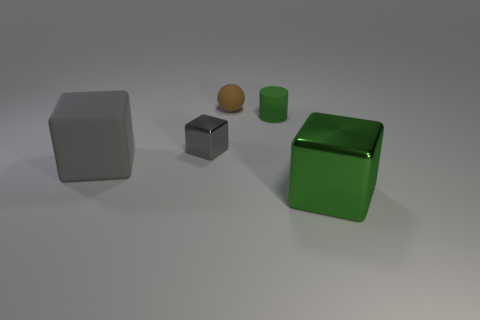Is there a small brown ball that has the same material as the small green thing?
Provide a short and direct response. Yes. Is the brown sphere made of the same material as the gray cube that is left of the tiny gray object?
Your response must be concise. Yes. There is a metal block that is the same size as the rubber ball; what is its color?
Your response must be concise. Gray. There is a metallic thing that is to the left of the big block that is in front of the matte block; how big is it?
Offer a terse response. Small. Is the color of the large rubber object the same as the small shiny block that is in front of the ball?
Keep it short and to the point. Yes. Are there fewer tiny green objects in front of the tiny gray metal block than blue rubber cubes?
Your answer should be very brief. No. What number of other things are the same size as the brown ball?
Provide a succinct answer. 2. There is a small thing to the left of the small brown rubber object; does it have the same shape as the big green thing?
Provide a succinct answer. Yes. Are there more small brown matte objects that are in front of the big gray matte cube than big green matte cylinders?
Make the answer very short. No. The thing that is behind the big gray object and in front of the small green matte thing is made of what material?
Keep it short and to the point. Metal. 